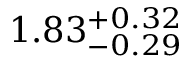<formula> <loc_0><loc_0><loc_500><loc_500>1 . 8 3 _ { - 0 . 2 9 } ^ { + 0 . 3 2 }</formula> 